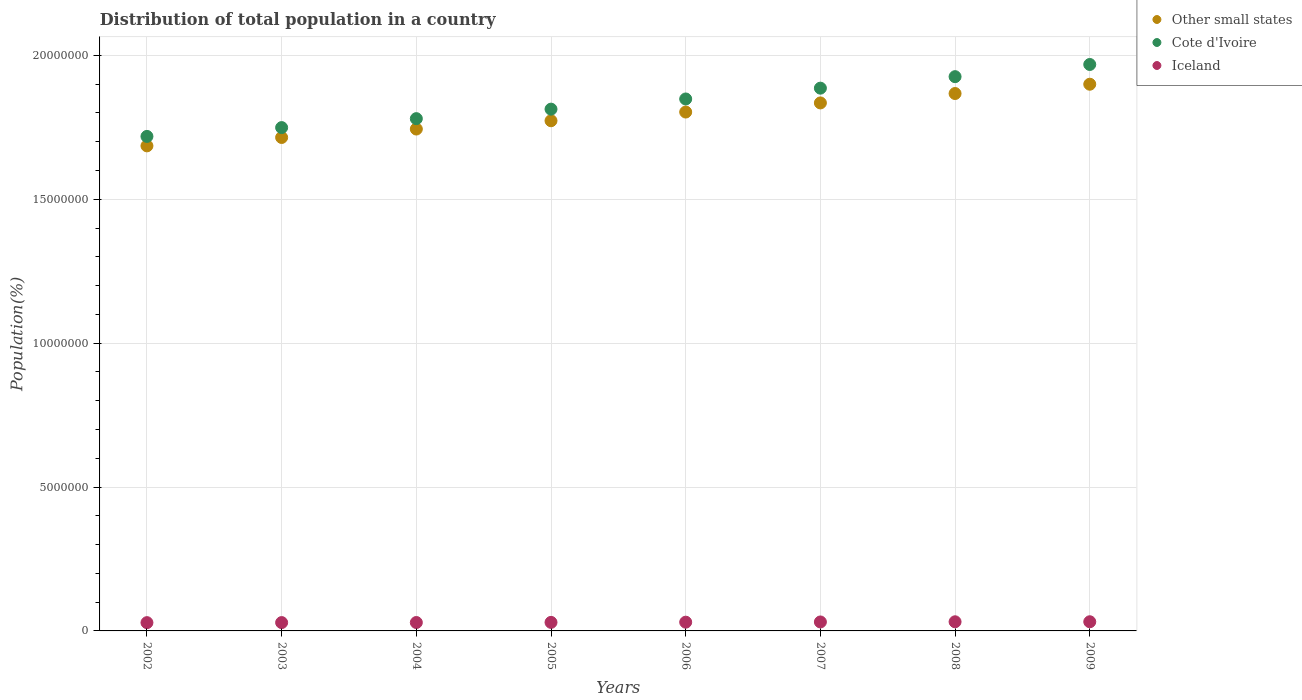Is the number of dotlines equal to the number of legend labels?
Provide a succinct answer. Yes. What is the population of in Cote d'Ivoire in 2009?
Offer a terse response. 1.97e+07. Across all years, what is the maximum population of in Cote d'Ivoire?
Keep it short and to the point. 1.97e+07. Across all years, what is the minimum population of in Iceland?
Your answer should be very brief. 2.88e+05. In which year was the population of in Iceland maximum?
Provide a succinct answer. 2009. In which year was the population of in Iceland minimum?
Your response must be concise. 2002. What is the total population of in Other small states in the graph?
Offer a very short reply. 1.43e+08. What is the difference between the population of in Other small states in 2003 and that in 2009?
Make the answer very short. -1.85e+06. What is the difference between the population of in Cote d'Ivoire in 2002 and the population of in Other small states in 2007?
Make the answer very short. -1.16e+06. What is the average population of in Iceland per year?
Provide a short and direct response. 3.02e+05. In the year 2004, what is the difference between the population of in Other small states and population of in Cote d'Ivoire?
Provide a short and direct response. -3.61e+05. In how many years, is the population of in Other small states greater than 18000000 %?
Ensure brevity in your answer.  4. What is the ratio of the population of in Iceland in 2003 to that in 2008?
Keep it short and to the point. 0.91. Is the difference between the population of in Other small states in 2003 and 2007 greater than the difference between the population of in Cote d'Ivoire in 2003 and 2007?
Make the answer very short. Yes. What is the difference between the highest and the second highest population of in Iceland?
Make the answer very short. 1085. What is the difference between the highest and the lowest population of in Cote d'Ivoire?
Give a very brief answer. 2.50e+06. Does the population of in Other small states monotonically increase over the years?
Give a very brief answer. Yes. What is the difference between two consecutive major ticks on the Y-axis?
Your answer should be compact. 5.00e+06. Are the values on the major ticks of Y-axis written in scientific E-notation?
Give a very brief answer. No. Does the graph contain any zero values?
Make the answer very short. No. What is the title of the graph?
Your answer should be compact. Distribution of total population in a country. Does "Libya" appear as one of the legend labels in the graph?
Your answer should be very brief. No. What is the label or title of the X-axis?
Provide a succinct answer. Years. What is the label or title of the Y-axis?
Your answer should be very brief. Population(%). What is the Population(%) in Other small states in 2002?
Offer a very short reply. 1.69e+07. What is the Population(%) of Cote d'Ivoire in 2002?
Ensure brevity in your answer.  1.72e+07. What is the Population(%) of Iceland in 2002?
Offer a very short reply. 2.88e+05. What is the Population(%) of Other small states in 2003?
Provide a short and direct response. 1.71e+07. What is the Population(%) of Cote d'Ivoire in 2003?
Ensure brevity in your answer.  1.75e+07. What is the Population(%) in Iceland in 2003?
Your answer should be very brief. 2.90e+05. What is the Population(%) of Other small states in 2004?
Your answer should be very brief. 1.74e+07. What is the Population(%) of Cote d'Ivoire in 2004?
Keep it short and to the point. 1.78e+07. What is the Population(%) in Iceland in 2004?
Offer a very short reply. 2.92e+05. What is the Population(%) in Other small states in 2005?
Provide a succinct answer. 1.77e+07. What is the Population(%) of Cote d'Ivoire in 2005?
Make the answer very short. 1.81e+07. What is the Population(%) of Iceland in 2005?
Provide a short and direct response. 2.97e+05. What is the Population(%) of Other small states in 2006?
Your response must be concise. 1.80e+07. What is the Population(%) of Cote d'Ivoire in 2006?
Make the answer very short. 1.85e+07. What is the Population(%) of Iceland in 2006?
Ensure brevity in your answer.  3.04e+05. What is the Population(%) in Other small states in 2007?
Keep it short and to the point. 1.83e+07. What is the Population(%) of Cote d'Ivoire in 2007?
Offer a very short reply. 1.89e+07. What is the Population(%) in Iceland in 2007?
Keep it short and to the point. 3.12e+05. What is the Population(%) of Other small states in 2008?
Your answer should be very brief. 1.87e+07. What is the Population(%) in Cote d'Ivoire in 2008?
Offer a very short reply. 1.93e+07. What is the Population(%) of Iceland in 2008?
Make the answer very short. 3.17e+05. What is the Population(%) of Other small states in 2009?
Keep it short and to the point. 1.90e+07. What is the Population(%) of Cote d'Ivoire in 2009?
Offer a terse response. 1.97e+07. What is the Population(%) of Iceland in 2009?
Offer a very short reply. 3.18e+05. Across all years, what is the maximum Population(%) of Other small states?
Provide a succinct answer. 1.90e+07. Across all years, what is the maximum Population(%) of Cote d'Ivoire?
Give a very brief answer. 1.97e+07. Across all years, what is the maximum Population(%) in Iceland?
Offer a very short reply. 3.18e+05. Across all years, what is the minimum Population(%) in Other small states?
Your answer should be very brief. 1.69e+07. Across all years, what is the minimum Population(%) in Cote d'Ivoire?
Your answer should be very brief. 1.72e+07. Across all years, what is the minimum Population(%) in Iceland?
Provide a short and direct response. 2.88e+05. What is the total Population(%) of Other small states in the graph?
Ensure brevity in your answer.  1.43e+08. What is the total Population(%) of Cote d'Ivoire in the graph?
Ensure brevity in your answer.  1.47e+08. What is the total Population(%) of Iceland in the graph?
Your response must be concise. 2.42e+06. What is the difference between the Population(%) of Other small states in 2002 and that in 2003?
Provide a succinct answer. -2.91e+05. What is the difference between the Population(%) in Cote d'Ivoire in 2002 and that in 2003?
Your answer should be compact. -3.06e+05. What is the difference between the Population(%) of Iceland in 2002 and that in 2003?
Make the answer very short. -1998. What is the difference between the Population(%) in Other small states in 2002 and that in 2004?
Give a very brief answer. -5.85e+05. What is the difference between the Population(%) in Cote d'Ivoire in 2002 and that in 2004?
Your response must be concise. -6.17e+05. What is the difference between the Population(%) in Iceland in 2002 and that in 2004?
Provide a succinct answer. -4551. What is the difference between the Population(%) of Other small states in 2002 and that in 2005?
Provide a succinct answer. -8.73e+05. What is the difference between the Population(%) in Cote d'Ivoire in 2002 and that in 2005?
Provide a succinct answer. -9.47e+05. What is the difference between the Population(%) of Iceland in 2002 and that in 2005?
Your answer should be very brief. -9211. What is the difference between the Population(%) of Other small states in 2002 and that in 2006?
Your response must be concise. -1.18e+06. What is the difference between the Population(%) of Cote d'Ivoire in 2002 and that in 2006?
Offer a terse response. -1.30e+06. What is the difference between the Population(%) in Iceland in 2002 and that in 2006?
Ensure brevity in your answer.  -1.63e+04. What is the difference between the Population(%) in Other small states in 2002 and that in 2007?
Offer a very short reply. -1.49e+06. What is the difference between the Population(%) of Cote d'Ivoire in 2002 and that in 2007?
Your answer should be compact. -1.68e+06. What is the difference between the Population(%) of Iceland in 2002 and that in 2007?
Your answer should be compact. -2.40e+04. What is the difference between the Population(%) of Other small states in 2002 and that in 2008?
Give a very brief answer. -1.82e+06. What is the difference between the Population(%) of Cote d'Ivoire in 2002 and that in 2008?
Provide a short and direct response. -2.08e+06. What is the difference between the Population(%) in Iceland in 2002 and that in 2008?
Ensure brevity in your answer.  -2.99e+04. What is the difference between the Population(%) of Other small states in 2002 and that in 2009?
Keep it short and to the point. -2.14e+06. What is the difference between the Population(%) in Cote d'Ivoire in 2002 and that in 2009?
Offer a very short reply. -2.50e+06. What is the difference between the Population(%) of Iceland in 2002 and that in 2009?
Give a very brief answer. -3.10e+04. What is the difference between the Population(%) in Other small states in 2003 and that in 2004?
Your response must be concise. -2.93e+05. What is the difference between the Population(%) of Cote d'Ivoire in 2003 and that in 2004?
Your answer should be compact. -3.11e+05. What is the difference between the Population(%) of Iceland in 2003 and that in 2004?
Offer a terse response. -2553. What is the difference between the Population(%) in Other small states in 2003 and that in 2005?
Keep it short and to the point. -5.82e+05. What is the difference between the Population(%) of Cote d'Ivoire in 2003 and that in 2005?
Your answer should be compact. -6.41e+05. What is the difference between the Population(%) in Iceland in 2003 and that in 2005?
Your answer should be very brief. -7213. What is the difference between the Population(%) in Other small states in 2003 and that in 2006?
Give a very brief answer. -8.84e+05. What is the difference between the Population(%) in Cote d'Ivoire in 2003 and that in 2006?
Keep it short and to the point. -9.95e+05. What is the difference between the Population(%) in Iceland in 2003 and that in 2006?
Your answer should be compact. -1.43e+04. What is the difference between the Population(%) of Other small states in 2003 and that in 2007?
Provide a succinct answer. -1.20e+06. What is the difference between the Population(%) in Cote d'Ivoire in 2003 and that in 2007?
Offer a terse response. -1.37e+06. What is the difference between the Population(%) of Iceland in 2003 and that in 2007?
Your response must be concise. -2.20e+04. What is the difference between the Population(%) of Other small states in 2003 and that in 2008?
Give a very brief answer. -1.53e+06. What is the difference between the Population(%) of Cote d'Ivoire in 2003 and that in 2008?
Keep it short and to the point. -1.77e+06. What is the difference between the Population(%) in Iceland in 2003 and that in 2008?
Provide a short and direct response. -2.79e+04. What is the difference between the Population(%) of Other small states in 2003 and that in 2009?
Make the answer very short. -1.85e+06. What is the difference between the Population(%) of Cote d'Ivoire in 2003 and that in 2009?
Provide a short and direct response. -2.19e+06. What is the difference between the Population(%) in Iceland in 2003 and that in 2009?
Provide a succinct answer. -2.90e+04. What is the difference between the Population(%) in Other small states in 2004 and that in 2005?
Your response must be concise. -2.88e+05. What is the difference between the Population(%) of Cote d'Ivoire in 2004 and that in 2005?
Keep it short and to the point. -3.30e+05. What is the difference between the Population(%) of Iceland in 2004 and that in 2005?
Make the answer very short. -4660. What is the difference between the Population(%) in Other small states in 2004 and that in 2006?
Offer a terse response. -5.91e+05. What is the difference between the Population(%) of Cote d'Ivoire in 2004 and that in 2006?
Provide a succinct answer. -6.84e+05. What is the difference between the Population(%) of Iceland in 2004 and that in 2006?
Offer a very short reply. -1.17e+04. What is the difference between the Population(%) of Other small states in 2004 and that in 2007?
Provide a short and direct response. -9.07e+05. What is the difference between the Population(%) in Cote d'Ivoire in 2004 and that in 2007?
Ensure brevity in your answer.  -1.06e+06. What is the difference between the Population(%) of Iceland in 2004 and that in 2007?
Ensure brevity in your answer.  -1.95e+04. What is the difference between the Population(%) of Other small states in 2004 and that in 2008?
Give a very brief answer. -1.23e+06. What is the difference between the Population(%) of Cote d'Ivoire in 2004 and that in 2008?
Offer a very short reply. -1.46e+06. What is the difference between the Population(%) in Iceland in 2004 and that in 2008?
Offer a very short reply. -2.53e+04. What is the difference between the Population(%) of Other small states in 2004 and that in 2009?
Provide a short and direct response. -1.56e+06. What is the difference between the Population(%) in Cote d'Ivoire in 2004 and that in 2009?
Your answer should be compact. -1.88e+06. What is the difference between the Population(%) of Iceland in 2004 and that in 2009?
Ensure brevity in your answer.  -2.64e+04. What is the difference between the Population(%) in Other small states in 2005 and that in 2006?
Your answer should be compact. -3.03e+05. What is the difference between the Population(%) in Cote d'Ivoire in 2005 and that in 2006?
Make the answer very short. -3.54e+05. What is the difference between the Population(%) in Iceland in 2005 and that in 2006?
Provide a short and direct response. -7048. What is the difference between the Population(%) in Other small states in 2005 and that in 2007?
Your answer should be compact. -6.19e+05. What is the difference between the Population(%) of Cote d'Ivoire in 2005 and that in 2007?
Ensure brevity in your answer.  -7.29e+05. What is the difference between the Population(%) in Iceland in 2005 and that in 2007?
Your answer should be very brief. -1.48e+04. What is the difference between the Population(%) in Other small states in 2005 and that in 2008?
Your answer should be compact. -9.46e+05. What is the difference between the Population(%) of Cote d'Ivoire in 2005 and that in 2008?
Your answer should be compact. -1.13e+06. What is the difference between the Population(%) of Iceland in 2005 and that in 2008?
Keep it short and to the point. -2.07e+04. What is the difference between the Population(%) of Other small states in 2005 and that in 2009?
Provide a succinct answer. -1.27e+06. What is the difference between the Population(%) in Cote d'Ivoire in 2005 and that in 2009?
Offer a terse response. -1.55e+06. What is the difference between the Population(%) of Iceland in 2005 and that in 2009?
Keep it short and to the point. -2.18e+04. What is the difference between the Population(%) of Other small states in 2006 and that in 2007?
Provide a succinct answer. -3.17e+05. What is the difference between the Population(%) in Cote d'Ivoire in 2006 and that in 2007?
Ensure brevity in your answer.  -3.76e+05. What is the difference between the Population(%) in Iceland in 2006 and that in 2007?
Offer a very short reply. -7784. What is the difference between the Population(%) of Other small states in 2006 and that in 2008?
Your response must be concise. -6.43e+05. What is the difference between the Population(%) in Cote d'Ivoire in 2006 and that in 2008?
Your answer should be compact. -7.75e+05. What is the difference between the Population(%) in Iceland in 2006 and that in 2008?
Keep it short and to the point. -1.36e+04. What is the difference between the Population(%) of Other small states in 2006 and that in 2009?
Your answer should be compact. -9.67e+05. What is the difference between the Population(%) in Cote d'Ivoire in 2006 and that in 2009?
Make the answer very short. -1.20e+06. What is the difference between the Population(%) in Iceland in 2006 and that in 2009?
Your answer should be very brief. -1.47e+04. What is the difference between the Population(%) in Other small states in 2007 and that in 2008?
Provide a short and direct response. -3.27e+05. What is the difference between the Population(%) in Cote d'Ivoire in 2007 and that in 2008?
Keep it short and to the point. -3.99e+05. What is the difference between the Population(%) of Iceland in 2007 and that in 2008?
Your answer should be very brief. -5848. What is the difference between the Population(%) in Other small states in 2007 and that in 2009?
Offer a terse response. -6.50e+05. What is the difference between the Population(%) of Cote d'Ivoire in 2007 and that in 2009?
Offer a terse response. -8.23e+05. What is the difference between the Population(%) in Iceland in 2007 and that in 2009?
Your answer should be compact. -6933. What is the difference between the Population(%) in Other small states in 2008 and that in 2009?
Offer a terse response. -3.23e+05. What is the difference between the Population(%) in Cote d'Ivoire in 2008 and that in 2009?
Ensure brevity in your answer.  -4.23e+05. What is the difference between the Population(%) in Iceland in 2008 and that in 2009?
Your response must be concise. -1085. What is the difference between the Population(%) in Other small states in 2002 and the Population(%) in Cote d'Ivoire in 2003?
Give a very brief answer. -6.35e+05. What is the difference between the Population(%) in Other small states in 2002 and the Population(%) in Iceland in 2003?
Offer a very short reply. 1.66e+07. What is the difference between the Population(%) in Cote d'Ivoire in 2002 and the Population(%) in Iceland in 2003?
Your answer should be compact. 1.69e+07. What is the difference between the Population(%) of Other small states in 2002 and the Population(%) of Cote d'Ivoire in 2004?
Make the answer very short. -9.46e+05. What is the difference between the Population(%) of Other small states in 2002 and the Population(%) of Iceland in 2004?
Your answer should be very brief. 1.66e+07. What is the difference between the Population(%) in Cote d'Ivoire in 2002 and the Population(%) in Iceland in 2004?
Provide a succinct answer. 1.69e+07. What is the difference between the Population(%) of Other small states in 2002 and the Population(%) of Cote d'Ivoire in 2005?
Provide a succinct answer. -1.28e+06. What is the difference between the Population(%) of Other small states in 2002 and the Population(%) of Iceland in 2005?
Provide a short and direct response. 1.66e+07. What is the difference between the Population(%) of Cote d'Ivoire in 2002 and the Population(%) of Iceland in 2005?
Provide a short and direct response. 1.69e+07. What is the difference between the Population(%) in Other small states in 2002 and the Population(%) in Cote d'Ivoire in 2006?
Keep it short and to the point. -1.63e+06. What is the difference between the Population(%) in Other small states in 2002 and the Population(%) in Iceland in 2006?
Provide a succinct answer. 1.66e+07. What is the difference between the Population(%) in Cote d'Ivoire in 2002 and the Population(%) in Iceland in 2006?
Ensure brevity in your answer.  1.69e+07. What is the difference between the Population(%) of Other small states in 2002 and the Population(%) of Cote d'Ivoire in 2007?
Your answer should be very brief. -2.01e+06. What is the difference between the Population(%) in Other small states in 2002 and the Population(%) in Iceland in 2007?
Offer a very short reply. 1.65e+07. What is the difference between the Population(%) in Cote d'Ivoire in 2002 and the Population(%) in Iceland in 2007?
Your response must be concise. 1.69e+07. What is the difference between the Population(%) of Other small states in 2002 and the Population(%) of Cote d'Ivoire in 2008?
Give a very brief answer. -2.40e+06. What is the difference between the Population(%) of Other small states in 2002 and the Population(%) of Iceland in 2008?
Your response must be concise. 1.65e+07. What is the difference between the Population(%) in Cote d'Ivoire in 2002 and the Population(%) in Iceland in 2008?
Ensure brevity in your answer.  1.69e+07. What is the difference between the Population(%) in Other small states in 2002 and the Population(%) in Cote d'Ivoire in 2009?
Give a very brief answer. -2.83e+06. What is the difference between the Population(%) of Other small states in 2002 and the Population(%) of Iceland in 2009?
Your answer should be very brief. 1.65e+07. What is the difference between the Population(%) in Cote d'Ivoire in 2002 and the Population(%) in Iceland in 2009?
Offer a terse response. 1.69e+07. What is the difference between the Population(%) of Other small states in 2003 and the Population(%) of Cote d'Ivoire in 2004?
Ensure brevity in your answer.  -6.54e+05. What is the difference between the Population(%) of Other small states in 2003 and the Population(%) of Iceland in 2004?
Provide a succinct answer. 1.69e+07. What is the difference between the Population(%) of Cote d'Ivoire in 2003 and the Population(%) of Iceland in 2004?
Keep it short and to the point. 1.72e+07. What is the difference between the Population(%) in Other small states in 2003 and the Population(%) in Cote d'Ivoire in 2005?
Keep it short and to the point. -9.85e+05. What is the difference between the Population(%) of Other small states in 2003 and the Population(%) of Iceland in 2005?
Make the answer very short. 1.69e+07. What is the difference between the Population(%) in Cote d'Ivoire in 2003 and the Population(%) in Iceland in 2005?
Keep it short and to the point. 1.72e+07. What is the difference between the Population(%) of Other small states in 2003 and the Population(%) of Cote d'Ivoire in 2006?
Your response must be concise. -1.34e+06. What is the difference between the Population(%) in Other small states in 2003 and the Population(%) in Iceland in 2006?
Make the answer very short. 1.68e+07. What is the difference between the Population(%) in Cote d'Ivoire in 2003 and the Population(%) in Iceland in 2006?
Provide a short and direct response. 1.72e+07. What is the difference between the Population(%) of Other small states in 2003 and the Population(%) of Cote d'Ivoire in 2007?
Make the answer very short. -1.71e+06. What is the difference between the Population(%) of Other small states in 2003 and the Population(%) of Iceland in 2007?
Your answer should be compact. 1.68e+07. What is the difference between the Population(%) in Cote d'Ivoire in 2003 and the Population(%) in Iceland in 2007?
Offer a very short reply. 1.72e+07. What is the difference between the Population(%) in Other small states in 2003 and the Population(%) in Cote d'Ivoire in 2008?
Provide a succinct answer. -2.11e+06. What is the difference between the Population(%) of Other small states in 2003 and the Population(%) of Iceland in 2008?
Your answer should be very brief. 1.68e+07. What is the difference between the Population(%) of Cote d'Ivoire in 2003 and the Population(%) of Iceland in 2008?
Make the answer very short. 1.72e+07. What is the difference between the Population(%) in Other small states in 2003 and the Population(%) in Cote d'Ivoire in 2009?
Give a very brief answer. -2.54e+06. What is the difference between the Population(%) of Other small states in 2003 and the Population(%) of Iceland in 2009?
Ensure brevity in your answer.  1.68e+07. What is the difference between the Population(%) of Cote d'Ivoire in 2003 and the Population(%) of Iceland in 2009?
Your response must be concise. 1.72e+07. What is the difference between the Population(%) in Other small states in 2004 and the Population(%) in Cote d'Ivoire in 2005?
Your answer should be very brief. -6.91e+05. What is the difference between the Population(%) of Other small states in 2004 and the Population(%) of Iceland in 2005?
Your response must be concise. 1.71e+07. What is the difference between the Population(%) of Cote d'Ivoire in 2004 and the Population(%) of Iceland in 2005?
Ensure brevity in your answer.  1.75e+07. What is the difference between the Population(%) of Other small states in 2004 and the Population(%) of Cote d'Ivoire in 2006?
Keep it short and to the point. -1.04e+06. What is the difference between the Population(%) of Other small states in 2004 and the Population(%) of Iceland in 2006?
Ensure brevity in your answer.  1.71e+07. What is the difference between the Population(%) in Cote d'Ivoire in 2004 and the Population(%) in Iceland in 2006?
Offer a very short reply. 1.75e+07. What is the difference between the Population(%) in Other small states in 2004 and the Population(%) in Cote d'Ivoire in 2007?
Provide a succinct answer. -1.42e+06. What is the difference between the Population(%) of Other small states in 2004 and the Population(%) of Iceland in 2007?
Make the answer very short. 1.71e+07. What is the difference between the Population(%) in Cote d'Ivoire in 2004 and the Population(%) in Iceland in 2007?
Your response must be concise. 1.75e+07. What is the difference between the Population(%) in Other small states in 2004 and the Population(%) in Cote d'Ivoire in 2008?
Provide a succinct answer. -1.82e+06. What is the difference between the Population(%) in Other small states in 2004 and the Population(%) in Iceland in 2008?
Keep it short and to the point. 1.71e+07. What is the difference between the Population(%) of Cote d'Ivoire in 2004 and the Population(%) of Iceland in 2008?
Your answer should be very brief. 1.75e+07. What is the difference between the Population(%) of Other small states in 2004 and the Population(%) of Cote d'Ivoire in 2009?
Keep it short and to the point. -2.24e+06. What is the difference between the Population(%) in Other small states in 2004 and the Population(%) in Iceland in 2009?
Offer a very short reply. 1.71e+07. What is the difference between the Population(%) in Cote d'Ivoire in 2004 and the Population(%) in Iceland in 2009?
Your answer should be compact. 1.75e+07. What is the difference between the Population(%) in Other small states in 2005 and the Population(%) in Cote d'Ivoire in 2006?
Give a very brief answer. -7.57e+05. What is the difference between the Population(%) of Other small states in 2005 and the Population(%) of Iceland in 2006?
Give a very brief answer. 1.74e+07. What is the difference between the Population(%) in Cote d'Ivoire in 2005 and the Population(%) in Iceland in 2006?
Give a very brief answer. 1.78e+07. What is the difference between the Population(%) of Other small states in 2005 and the Population(%) of Cote d'Ivoire in 2007?
Provide a succinct answer. -1.13e+06. What is the difference between the Population(%) of Other small states in 2005 and the Population(%) of Iceland in 2007?
Ensure brevity in your answer.  1.74e+07. What is the difference between the Population(%) of Cote d'Ivoire in 2005 and the Population(%) of Iceland in 2007?
Your response must be concise. 1.78e+07. What is the difference between the Population(%) of Other small states in 2005 and the Population(%) of Cote d'Ivoire in 2008?
Offer a terse response. -1.53e+06. What is the difference between the Population(%) of Other small states in 2005 and the Population(%) of Iceland in 2008?
Offer a terse response. 1.74e+07. What is the difference between the Population(%) in Cote d'Ivoire in 2005 and the Population(%) in Iceland in 2008?
Offer a very short reply. 1.78e+07. What is the difference between the Population(%) of Other small states in 2005 and the Population(%) of Cote d'Ivoire in 2009?
Offer a very short reply. -1.96e+06. What is the difference between the Population(%) of Other small states in 2005 and the Population(%) of Iceland in 2009?
Provide a short and direct response. 1.74e+07. What is the difference between the Population(%) in Cote d'Ivoire in 2005 and the Population(%) in Iceland in 2009?
Ensure brevity in your answer.  1.78e+07. What is the difference between the Population(%) of Other small states in 2006 and the Population(%) of Cote d'Ivoire in 2007?
Your answer should be very brief. -8.30e+05. What is the difference between the Population(%) of Other small states in 2006 and the Population(%) of Iceland in 2007?
Provide a succinct answer. 1.77e+07. What is the difference between the Population(%) of Cote d'Ivoire in 2006 and the Population(%) of Iceland in 2007?
Provide a succinct answer. 1.82e+07. What is the difference between the Population(%) of Other small states in 2006 and the Population(%) of Cote d'Ivoire in 2008?
Your answer should be compact. -1.23e+06. What is the difference between the Population(%) of Other small states in 2006 and the Population(%) of Iceland in 2008?
Give a very brief answer. 1.77e+07. What is the difference between the Population(%) in Cote d'Ivoire in 2006 and the Population(%) in Iceland in 2008?
Your answer should be very brief. 1.82e+07. What is the difference between the Population(%) in Other small states in 2006 and the Population(%) in Cote d'Ivoire in 2009?
Provide a succinct answer. -1.65e+06. What is the difference between the Population(%) in Other small states in 2006 and the Population(%) in Iceland in 2009?
Your answer should be compact. 1.77e+07. What is the difference between the Population(%) of Cote d'Ivoire in 2006 and the Population(%) of Iceland in 2009?
Offer a terse response. 1.82e+07. What is the difference between the Population(%) of Other small states in 2007 and the Population(%) of Cote d'Ivoire in 2008?
Your answer should be very brief. -9.13e+05. What is the difference between the Population(%) in Other small states in 2007 and the Population(%) in Iceland in 2008?
Offer a terse response. 1.80e+07. What is the difference between the Population(%) of Cote d'Ivoire in 2007 and the Population(%) of Iceland in 2008?
Offer a terse response. 1.85e+07. What is the difference between the Population(%) in Other small states in 2007 and the Population(%) in Cote d'Ivoire in 2009?
Offer a very short reply. -1.34e+06. What is the difference between the Population(%) of Other small states in 2007 and the Population(%) of Iceland in 2009?
Ensure brevity in your answer.  1.80e+07. What is the difference between the Population(%) of Cote d'Ivoire in 2007 and the Population(%) of Iceland in 2009?
Keep it short and to the point. 1.85e+07. What is the difference between the Population(%) of Other small states in 2008 and the Population(%) of Cote d'Ivoire in 2009?
Offer a terse response. -1.01e+06. What is the difference between the Population(%) in Other small states in 2008 and the Population(%) in Iceland in 2009?
Make the answer very short. 1.84e+07. What is the difference between the Population(%) of Cote d'Ivoire in 2008 and the Population(%) of Iceland in 2009?
Ensure brevity in your answer.  1.89e+07. What is the average Population(%) in Other small states per year?
Give a very brief answer. 1.79e+07. What is the average Population(%) of Cote d'Ivoire per year?
Ensure brevity in your answer.  1.84e+07. What is the average Population(%) in Iceland per year?
Provide a succinct answer. 3.02e+05. In the year 2002, what is the difference between the Population(%) of Other small states and Population(%) of Cote d'Ivoire?
Provide a short and direct response. -3.29e+05. In the year 2002, what is the difference between the Population(%) in Other small states and Population(%) in Iceland?
Your answer should be very brief. 1.66e+07. In the year 2002, what is the difference between the Population(%) in Cote d'Ivoire and Population(%) in Iceland?
Offer a very short reply. 1.69e+07. In the year 2003, what is the difference between the Population(%) in Other small states and Population(%) in Cote d'Ivoire?
Provide a succinct answer. -3.43e+05. In the year 2003, what is the difference between the Population(%) in Other small states and Population(%) in Iceland?
Your answer should be very brief. 1.69e+07. In the year 2003, what is the difference between the Population(%) in Cote d'Ivoire and Population(%) in Iceland?
Ensure brevity in your answer.  1.72e+07. In the year 2004, what is the difference between the Population(%) of Other small states and Population(%) of Cote d'Ivoire?
Offer a very short reply. -3.61e+05. In the year 2004, what is the difference between the Population(%) of Other small states and Population(%) of Iceland?
Provide a short and direct response. 1.71e+07. In the year 2004, what is the difference between the Population(%) in Cote d'Ivoire and Population(%) in Iceland?
Provide a short and direct response. 1.75e+07. In the year 2005, what is the difference between the Population(%) of Other small states and Population(%) of Cote d'Ivoire?
Provide a short and direct response. -4.03e+05. In the year 2005, what is the difference between the Population(%) of Other small states and Population(%) of Iceland?
Provide a short and direct response. 1.74e+07. In the year 2005, what is the difference between the Population(%) of Cote d'Ivoire and Population(%) of Iceland?
Keep it short and to the point. 1.78e+07. In the year 2006, what is the difference between the Population(%) of Other small states and Population(%) of Cote d'Ivoire?
Offer a terse response. -4.54e+05. In the year 2006, what is the difference between the Population(%) in Other small states and Population(%) in Iceland?
Give a very brief answer. 1.77e+07. In the year 2006, what is the difference between the Population(%) in Cote d'Ivoire and Population(%) in Iceland?
Keep it short and to the point. 1.82e+07. In the year 2007, what is the difference between the Population(%) of Other small states and Population(%) of Cote d'Ivoire?
Offer a terse response. -5.13e+05. In the year 2007, what is the difference between the Population(%) in Other small states and Population(%) in Iceland?
Your answer should be compact. 1.80e+07. In the year 2007, what is the difference between the Population(%) of Cote d'Ivoire and Population(%) of Iceland?
Ensure brevity in your answer.  1.86e+07. In the year 2008, what is the difference between the Population(%) in Other small states and Population(%) in Cote d'Ivoire?
Make the answer very short. -5.86e+05. In the year 2008, what is the difference between the Population(%) in Other small states and Population(%) in Iceland?
Give a very brief answer. 1.84e+07. In the year 2008, what is the difference between the Population(%) in Cote d'Ivoire and Population(%) in Iceland?
Give a very brief answer. 1.89e+07. In the year 2009, what is the difference between the Population(%) in Other small states and Population(%) in Cote d'Ivoire?
Your response must be concise. -6.86e+05. In the year 2009, what is the difference between the Population(%) of Other small states and Population(%) of Iceland?
Your answer should be very brief. 1.87e+07. In the year 2009, what is the difference between the Population(%) of Cote d'Ivoire and Population(%) of Iceland?
Make the answer very short. 1.94e+07. What is the ratio of the Population(%) in Cote d'Ivoire in 2002 to that in 2003?
Provide a succinct answer. 0.98. What is the ratio of the Population(%) in Other small states in 2002 to that in 2004?
Provide a succinct answer. 0.97. What is the ratio of the Population(%) in Cote d'Ivoire in 2002 to that in 2004?
Provide a succinct answer. 0.97. What is the ratio of the Population(%) of Iceland in 2002 to that in 2004?
Your answer should be compact. 0.98. What is the ratio of the Population(%) in Other small states in 2002 to that in 2005?
Ensure brevity in your answer.  0.95. What is the ratio of the Population(%) of Cote d'Ivoire in 2002 to that in 2005?
Ensure brevity in your answer.  0.95. What is the ratio of the Population(%) of Other small states in 2002 to that in 2006?
Your response must be concise. 0.93. What is the ratio of the Population(%) in Cote d'Ivoire in 2002 to that in 2006?
Ensure brevity in your answer.  0.93. What is the ratio of the Population(%) in Iceland in 2002 to that in 2006?
Give a very brief answer. 0.95. What is the ratio of the Population(%) in Other small states in 2002 to that in 2007?
Give a very brief answer. 0.92. What is the ratio of the Population(%) in Cote d'Ivoire in 2002 to that in 2007?
Give a very brief answer. 0.91. What is the ratio of the Population(%) in Iceland in 2002 to that in 2007?
Provide a short and direct response. 0.92. What is the ratio of the Population(%) of Other small states in 2002 to that in 2008?
Provide a short and direct response. 0.9. What is the ratio of the Population(%) of Cote d'Ivoire in 2002 to that in 2008?
Ensure brevity in your answer.  0.89. What is the ratio of the Population(%) of Iceland in 2002 to that in 2008?
Provide a short and direct response. 0.91. What is the ratio of the Population(%) of Other small states in 2002 to that in 2009?
Your answer should be very brief. 0.89. What is the ratio of the Population(%) in Cote d'Ivoire in 2002 to that in 2009?
Offer a very short reply. 0.87. What is the ratio of the Population(%) of Iceland in 2002 to that in 2009?
Offer a terse response. 0.9. What is the ratio of the Population(%) of Other small states in 2003 to that in 2004?
Your response must be concise. 0.98. What is the ratio of the Population(%) of Cote d'Ivoire in 2003 to that in 2004?
Your answer should be compact. 0.98. What is the ratio of the Population(%) in Other small states in 2003 to that in 2005?
Your answer should be compact. 0.97. What is the ratio of the Population(%) of Cote d'Ivoire in 2003 to that in 2005?
Give a very brief answer. 0.96. What is the ratio of the Population(%) of Iceland in 2003 to that in 2005?
Keep it short and to the point. 0.98. What is the ratio of the Population(%) of Other small states in 2003 to that in 2006?
Provide a succinct answer. 0.95. What is the ratio of the Population(%) in Cote d'Ivoire in 2003 to that in 2006?
Your response must be concise. 0.95. What is the ratio of the Population(%) of Iceland in 2003 to that in 2006?
Your response must be concise. 0.95. What is the ratio of the Population(%) in Other small states in 2003 to that in 2007?
Keep it short and to the point. 0.93. What is the ratio of the Population(%) of Cote d'Ivoire in 2003 to that in 2007?
Make the answer very short. 0.93. What is the ratio of the Population(%) in Iceland in 2003 to that in 2007?
Ensure brevity in your answer.  0.93. What is the ratio of the Population(%) in Other small states in 2003 to that in 2008?
Give a very brief answer. 0.92. What is the ratio of the Population(%) in Cote d'Ivoire in 2003 to that in 2008?
Provide a short and direct response. 0.91. What is the ratio of the Population(%) in Iceland in 2003 to that in 2008?
Your answer should be very brief. 0.91. What is the ratio of the Population(%) in Other small states in 2003 to that in 2009?
Provide a short and direct response. 0.9. What is the ratio of the Population(%) of Cote d'Ivoire in 2003 to that in 2009?
Give a very brief answer. 0.89. What is the ratio of the Population(%) of Iceland in 2003 to that in 2009?
Keep it short and to the point. 0.91. What is the ratio of the Population(%) of Other small states in 2004 to that in 2005?
Your answer should be compact. 0.98. What is the ratio of the Population(%) of Cote d'Ivoire in 2004 to that in 2005?
Provide a succinct answer. 0.98. What is the ratio of the Population(%) of Iceland in 2004 to that in 2005?
Your answer should be very brief. 0.98. What is the ratio of the Population(%) of Other small states in 2004 to that in 2006?
Give a very brief answer. 0.97. What is the ratio of the Population(%) in Iceland in 2004 to that in 2006?
Ensure brevity in your answer.  0.96. What is the ratio of the Population(%) of Other small states in 2004 to that in 2007?
Keep it short and to the point. 0.95. What is the ratio of the Population(%) of Cote d'Ivoire in 2004 to that in 2007?
Your response must be concise. 0.94. What is the ratio of the Population(%) in Iceland in 2004 to that in 2007?
Offer a very short reply. 0.94. What is the ratio of the Population(%) in Other small states in 2004 to that in 2008?
Ensure brevity in your answer.  0.93. What is the ratio of the Population(%) in Cote d'Ivoire in 2004 to that in 2008?
Make the answer very short. 0.92. What is the ratio of the Population(%) in Iceland in 2004 to that in 2008?
Give a very brief answer. 0.92. What is the ratio of the Population(%) of Other small states in 2004 to that in 2009?
Offer a terse response. 0.92. What is the ratio of the Population(%) in Cote d'Ivoire in 2004 to that in 2009?
Offer a very short reply. 0.9. What is the ratio of the Population(%) of Iceland in 2004 to that in 2009?
Provide a succinct answer. 0.92. What is the ratio of the Population(%) in Other small states in 2005 to that in 2006?
Your response must be concise. 0.98. What is the ratio of the Population(%) in Cote d'Ivoire in 2005 to that in 2006?
Your response must be concise. 0.98. What is the ratio of the Population(%) in Iceland in 2005 to that in 2006?
Your response must be concise. 0.98. What is the ratio of the Population(%) of Other small states in 2005 to that in 2007?
Your response must be concise. 0.97. What is the ratio of the Population(%) of Cote d'Ivoire in 2005 to that in 2007?
Offer a terse response. 0.96. What is the ratio of the Population(%) in Other small states in 2005 to that in 2008?
Your answer should be very brief. 0.95. What is the ratio of the Population(%) of Cote d'Ivoire in 2005 to that in 2008?
Give a very brief answer. 0.94. What is the ratio of the Population(%) in Iceland in 2005 to that in 2008?
Provide a succinct answer. 0.93. What is the ratio of the Population(%) in Other small states in 2005 to that in 2009?
Offer a very short reply. 0.93. What is the ratio of the Population(%) in Cote d'Ivoire in 2005 to that in 2009?
Ensure brevity in your answer.  0.92. What is the ratio of the Population(%) of Iceland in 2005 to that in 2009?
Make the answer very short. 0.93. What is the ratio of the Population(%) of Other small states in 2006 to that in 2007?
Keep it short and to the point. 0.98. What is the ratio of the Population(%) in Cote d'Ivoire in 2006 to that in 2007?
Keep it short and to the point. 0.98. What is the ratio of the Population(%) of Other small states in 2006 to that in 2008?
Provide a succinct answer. 0.97. What is the ratio of the Population(%) of Cote d'Ivoire in 2006 to that in 2008?
Your answer should be compact. 0.96. What is the ratio of the Population(%) of Iceland in 2006 to that in 2008?
Keep it short and to the point. 0.96. What is the ratio of the Population(%) in Other small states in 2006 to that in 2009?
Make the answer very short. 0.95. What is the ratio of the Population(%) of Cote d'Ivoire in 2006 to that in 2009?
Keep it short and to the point. 0.94. What is the ratio of the Population(%) of Iceland in 2006 to that in 2009?
Keep it short and to the point. 0.95. What is the ratio of the Population(%) in Other small states in 2007 to that in 2008?
Make the answer very short. 0.98. What is the ratio of the Population(%) in Cote d'Ivoire in 2007 to that in 2008?
Make the answer very short. 0.98. What is the ratio of the Population(%) of Iceland in 2007 to that in 2008?
Provide a short and direct response. 0.98. What is the ratio of the Population(%) of Other small states in 2007 to that in 2009?
Your answer should be compact. 0.97. What is the ratio of the Population(%) in Cote d'Ivoire in 2007 to that in 2009?
Make the answer very short. 0.96. What is the ratio of the Population(%) in Iceland in 2007 to that in 2009?
Provide a succinct answer. 0.98. What is the ratio of the Population(%) in Other small states in 2008 to that in 2009?
Make the answer very short. 0.98. What is the ratio of the Population(%) of Cote d'Ivoire in 2008 to that in 2009?
Offer a very short reply. 0.98. What is the difference between the highest and the second highest Population(%) of Other small states?
Your answer should be very brief. 3.23e+05. What is the difference between the highest and the second highest Population(%) of Cote d'Ivoire?
Offer a very short reply. 4.23e+05. What is the difference between the highest and the second highest Population(%) in Iceland?
Keep it short and to the point. 1085. What is the difference between the highest and the lowest Population(%) of Other small states?
Provide a short and direct response. 2.14e+06. What is the difference between the highest and the lowest Population(%) in Cote d'Ivoire?
Offer a very short reply. 2.50e+06. What is the difference between the highest and the lowest Population(%) in Iceland?
Keep it short and to the point. 3.10e+04. 